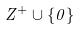<formula> <loc_0><loc_0><loc_500><loc_500>Z ^ { + } \cup \{ 0 \}</formula> 